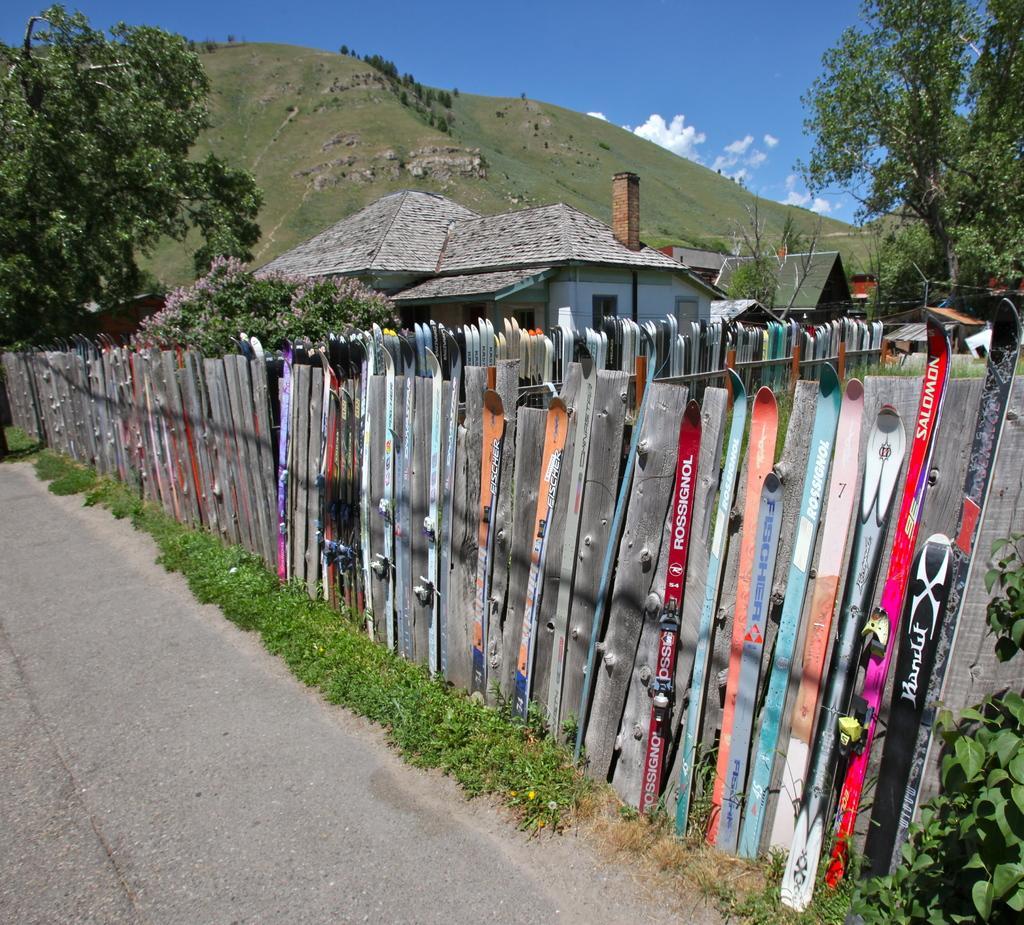Please provide a concise description of this image. In this image, we can see a fence. There are some plants beside the road. There is a shelter house in between trees. There is a hill and sky at the top of the image. 